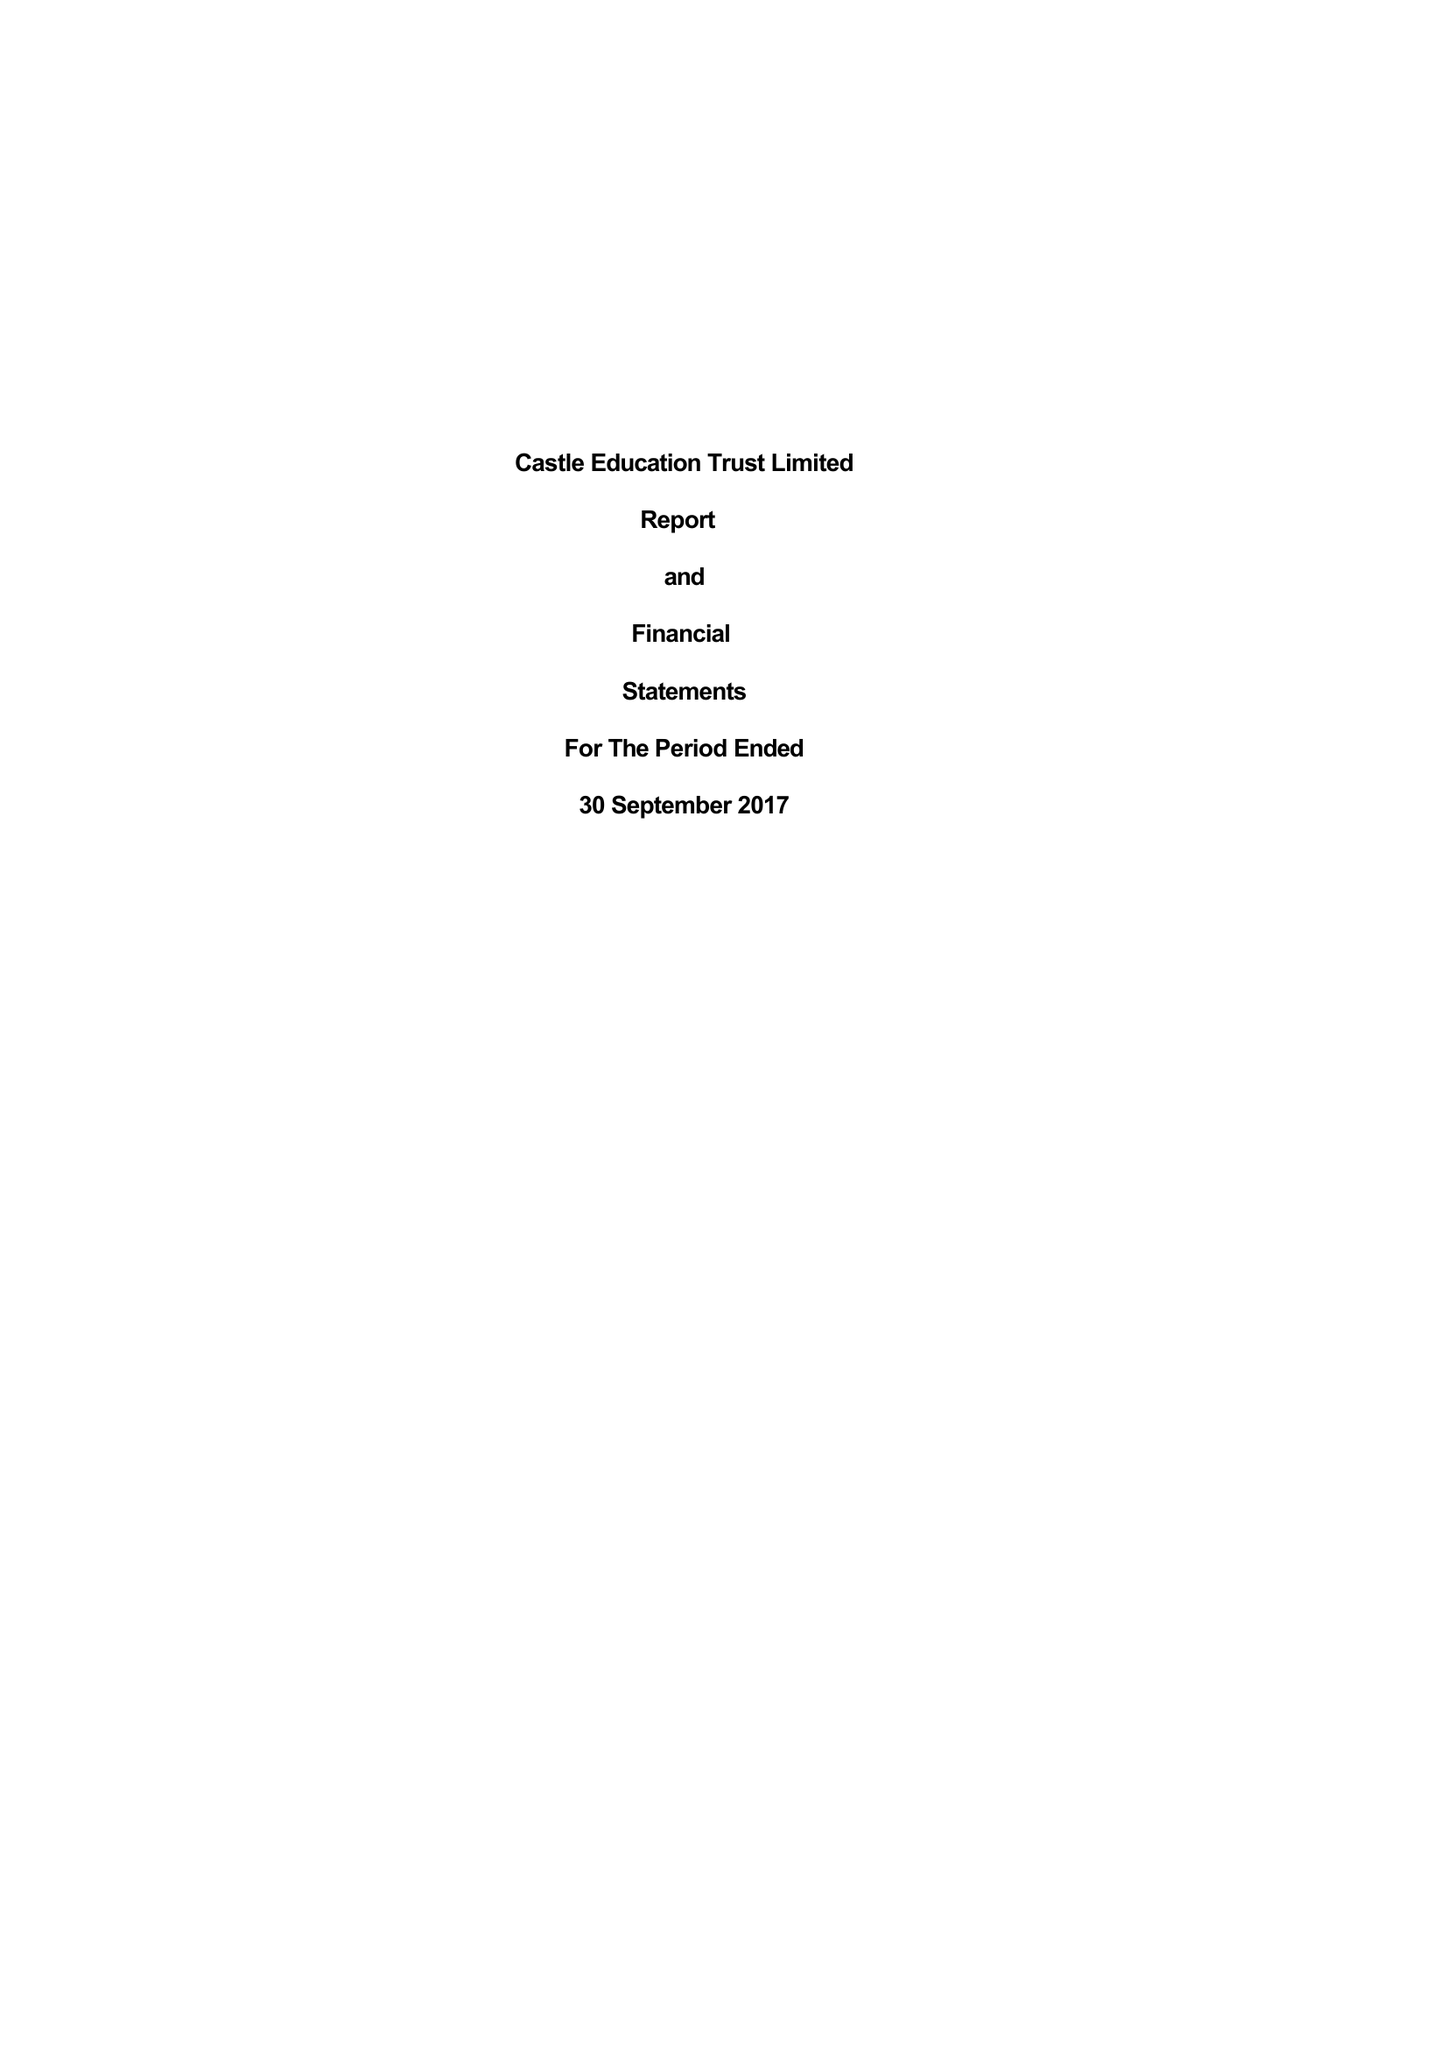What is the value for the report_date?
Answer the question using a single word or phrase. 2017-09-30 